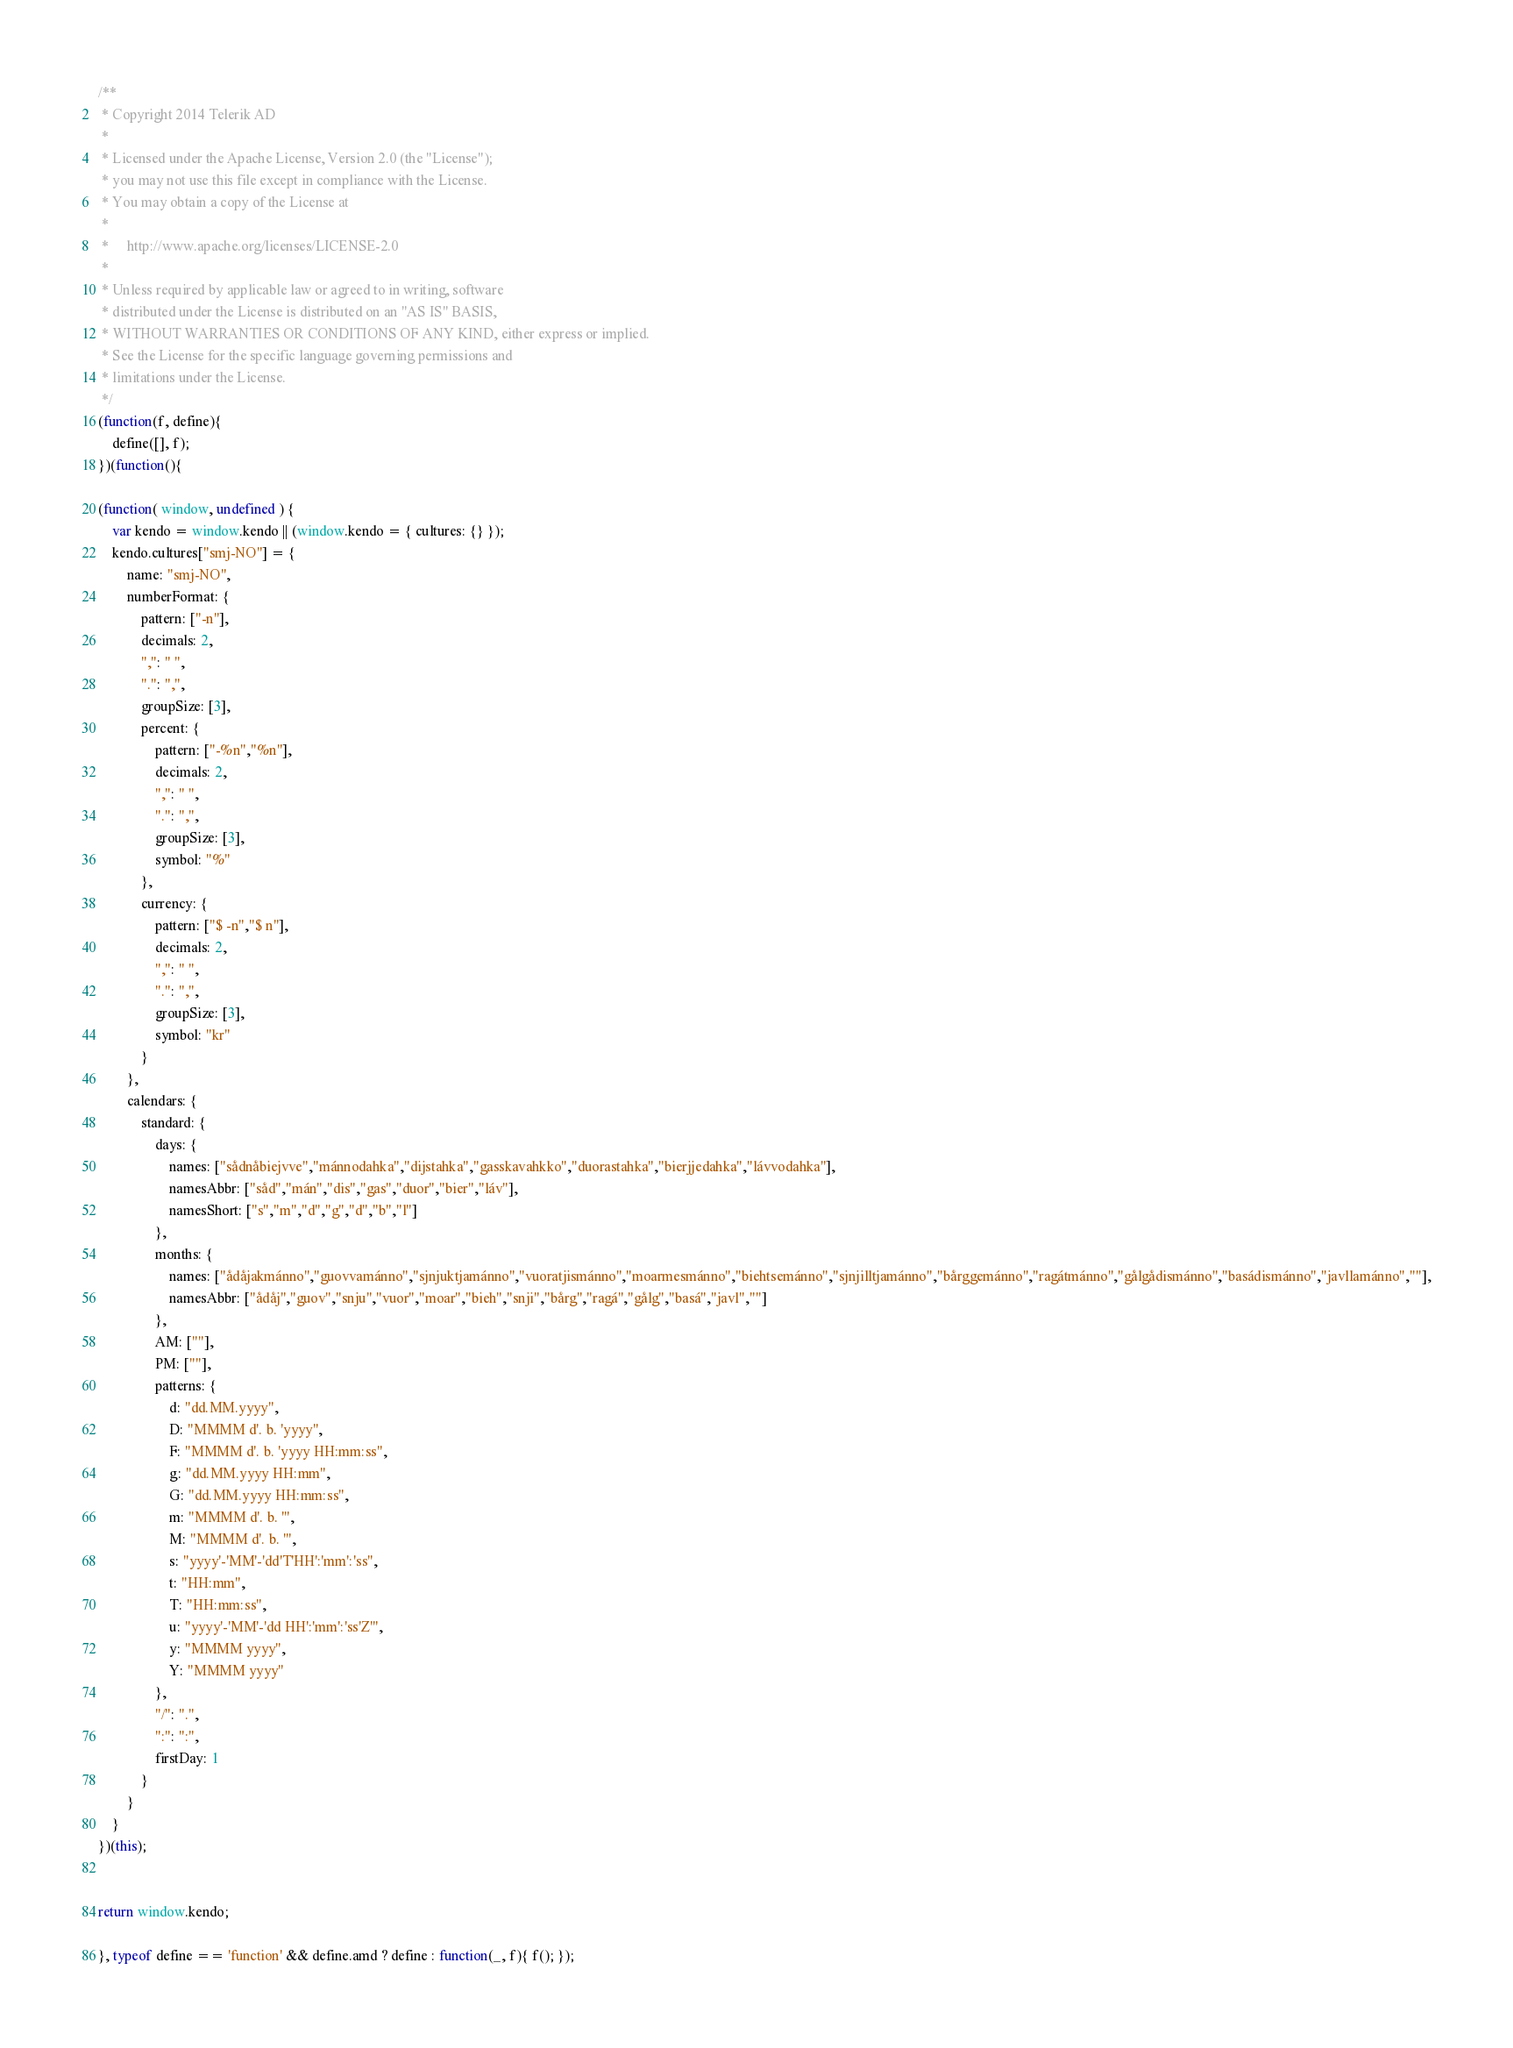<code> <loc_0><loc_0><loc_500><loc_500><_JavaScript_>/**
 * Copyright 2014 Telerik AD
 *
 * Licensed under the Apache License, Version 2.0 (the "License");
 * you may not use this file except in compliance with the License.
 * You may obtain a copy of the License at
 *
 *     http://www.apache.org/licenses/LICENSE-2.0
 *
 * Unless required by applicable law or agreed to in writing, software
 * distributed under the License is distributed on an "AS IS" BASIS,
 * WITHOUT WARRANTIES OR CONDITIONS OF ANY KIND, either express or implied.
 * See the License for the specific language governing permissions and
 * limitations under the License.
 */
(function(f, define){
    define([], f);
})(function(){

(function( window, undefined ) {
    var kendo = window.kendo || (window.kendo = { cultures: {} });
    kendo.cultures["smj-NO"] = {
        name: "smj-NO",
        numberFormat: {
            pattern: ["-n"],
            decimals: 2,
            ",": " ",
            ".": ",",
            groupSize: [3],
            percent: {
                pattern: ["-%n","%n"],
                decimals: 2,
                ",": " ",
                ".": ",",
                groupSize: [3],
                symbol: "%"
            },
            currency: {
                pattern: ["$ -n","$ n"],
                decimals: 2,
                ",": " ",
                ".": ",",
                groupSize: [3],
                symbol: "kr"
            }
        },
        calendars: {
            standard: {
                days: {
                    names: ["sådnåbiejvve","mánnodahka","dijstahka","gasskavahkko","duorastahka","bierjjedahka","lávvodahka"],
                    namesAbbr: ["såd","mán","dis","gas","duor","bier","láv"],
                    namesShort: ["s","m","d","g","d","b","l"]
                },
                months: {
                    names: ["ådåjakmánno","guovvamánno","sjnjuktjamánno","vuoratjismánno","moarmesmánno","biehtsemánno","sjnjilltjamánno","bårggemánno","ragátmánno","gålgådismánno","basádismánno","javllamánno",""],
                    namesAbbr: ["ådåj","guov","snju","vuor","moar","bieh","snji","bårg","ragá","gålg","basá","javl",""]
                },
                AM: [""],
                PM: [""],
                patterns: {
                    d: "dd.MM.yyyy",
                    D: "MMMM d'. b. 'yyyy",
                    F: "MMMM d'. b. 'yyyy HH:mm:ss",
                    g: "dd.MM.yyyy HH:mm",
                    G: "dd.MM.yyyy HH:mm:ss",
                    m: "MMMM d'. b. '",
                    M: "MMMM d'. b. '",
                    s: "yyyy'-'MM'-'dd'T'HH':'mm':'ss",
                    t: "HH:mm",
                    T: "HH:mm:ss",
                    u: "yyyy'-'MM'-'dd HH':'mm':'ss'Z'",
                    y: "MMMM yyyy",
                    Y: "MMMM yyyy"
                },
                "/": ".",
                ":": ":",
                firstDay: 1
            }
        }
    }
})(this);


return window.kendo;

}, typeof define == 'function' && define.amd ? define : function(_, f){ f(); });</code> 